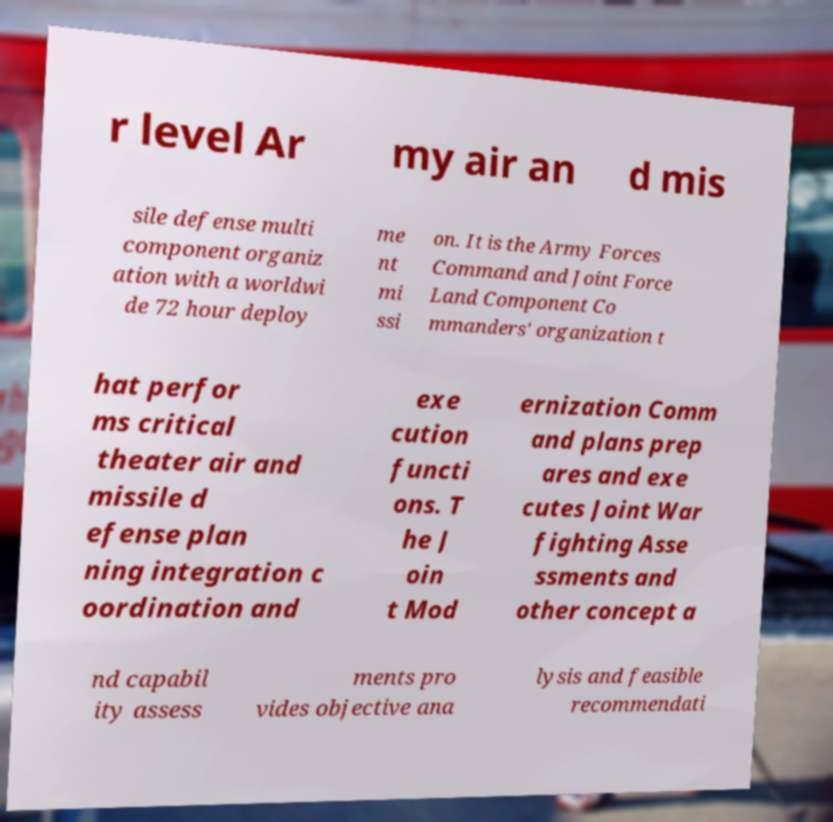For documentation purposes, I need the text within this image transcribed. Could you provide that? r level Ar my air an d mis sile defense multi component organiz ation with a worldwi de 72 hour deploy me nt mi ssi on. It is the Army Forces Command and Joint Force Land Component Co mmanders' organization t hat perfor ms critical theater air and missile d efense plan ning integration c oordination and exe cution functi ons. T he J oin t Mod ernization Comm and plans prep ares and exe cutes Joint War fighting Asse ssments and other concept a nd capabil ity assess ments pro vides objective ana lysis and feasible recommendati 